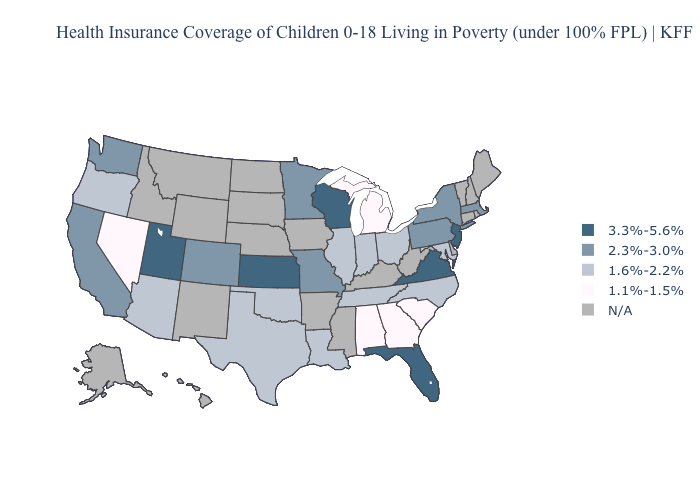Which states have the lowest value in the Northeast?
Give a very brief answer. Massachusetts, New York, Pennsylvania. Which states have the lowest value in the West?
Short answer required. Nevada. Name the states that have a value in the range 1.6%-2.2%?
Quick response, please. Arizona, Illinois, Indiana, Louisiana, Maryland, North Carolina, Ohio, Oklahoma, Oregon, Tennessee, Texas. Name the states that have a value in the range 2.3%-3.0%?
Keep it brief. California, Colorado, Massachusetts, Minnesota, Missouri, New York, Pennsylvania, Washington. What is the highest value in the USA?
Be succinct. 3.3%-5.6%. How many symbols are there in the legend?
Be succinct. 5. Name the states that have a value in the range 3.3%-5.6%?
Keep it brief. Florida, Kansas, New Jersey, Utah, Virginia, Wisconsin. What is the highest value in states that border New York?
Answer briefly. 3.3%-5.6%. Which states have the highest value in the USA?
Give a very brief answer. Florida, Kansas, New Jersey, Utah, Virginia, Wisconsin. What is the value of Alabama?
Concise answer only. 1.1%-1.5%. Does Florida have the highest value in the South?
Give a very brief answer. Yes. 